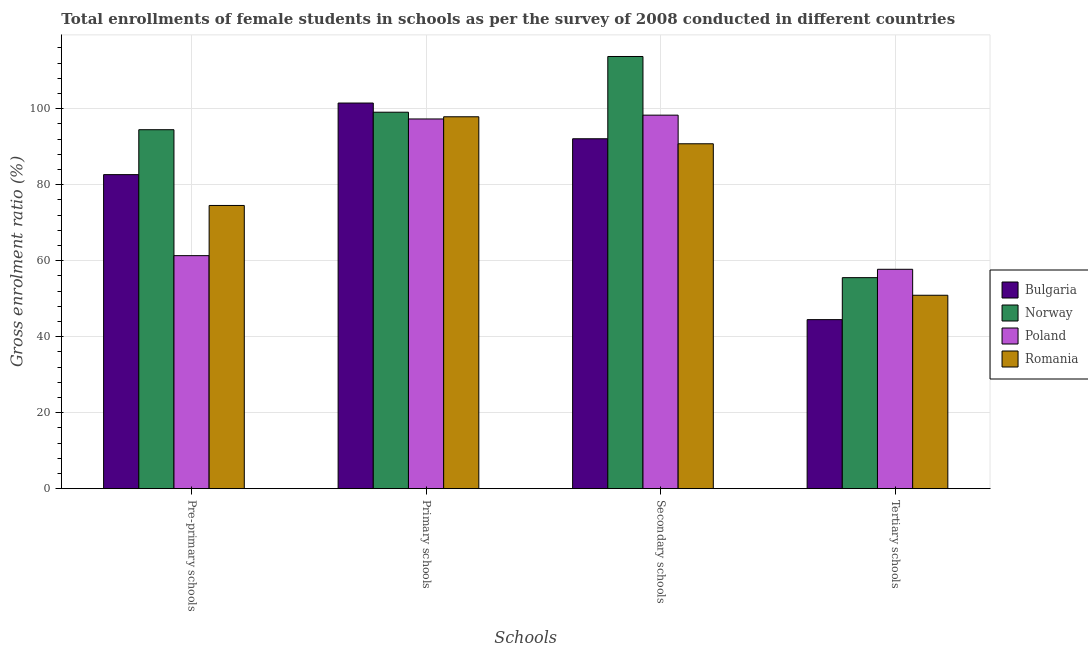Are the number of bars per tick equal to the number of legend labels?
Keep it short and to the point. Yes. Are the number of bars on each tick of the X-axis equal?
Provide a short and direct response. Yes. How many bars are there on the 1st tick from the right?
Your answer should be very brief. 4. What is the label of the 2nd group of bars from the left?
Provide a succinct answer. Primary schools. What is the gross enrolment ratio(female) in primary schools in Poland?
Provide a short and direct response. 97.31. Across all countries, what is the maximum gross enrolment ratio(female) in secondary schools?
Provide a succinct answer. 113.75. Across all countries, what is the minimum gross enrolment ratio(female) in secondary schools?
Ensure brevity in your answer.  90.78. In which country was the gross enrolment ratio(female) in primary schools minimum?
Your answer should be very brief. Poland. What is the total gross enrolment ratio(female) in tertiary schools in the graph?
Make the answer very short. 208.68. What is the difference between the gross enrolment ratio(female) in secondary schools in Bulgaria and that in Romania?
Keep it short and to the point. 1.32. What is the difference between the gross enrolment ratio(female) in secondary schools in Norway and the gross enrolment ratio(female) in primary schools in Bulgaria?
Make the answer very short. 12.25. What is the average gross enrolment ratio(female) in pre-primary schools per country?
Keep it short and to the point. 78.25. What is the difference between the gross enrolment ratio(female) in secondary schools and gross enrolment ratio(female) in primary schools in Poland?
Offer a very short reply. 1. In how many countries, is the gross enrolment ratio(female) in secondary schools greater than 48 %?
Your answer should be compact. 4. What is the ratio of the gross enrolment ratio(female) in primary schools in Poland to that in Romania?
Your response must be concise. 0.99. Is the gross enrolment ratio(female) in tertiary schools in Norway less than that in Romania?
Your response must be concise. No. Is the difference between the gross enrolment ratio(female) in tertiary schools in Norway and Bulgaria greater than the difference between the gross enrolment ratio(female) in primary schools in Norway and Bulgaria?
Keep it short and to the point. Yes. What is the difference between the highest and the second highest gross enrolment ratio(female) in secondary schools?
Give a very brief answer. 15.44. What is the difference between the highest and the lowest gross enrolment ratio(female) in pre-primary schools?
Provide a short and direct response. 33.15. In how many countries, is the gross enrolment ratio(female) in pre-primary schools greater than the average gross enrolment ratio(female) in pre-primary schools taken over all countries?
Provide a short and direct response. 2. Is the sum of the gross enrolment ratio(female) in secondary schools in Norway and Romania greater than the maximum gross enrolment ratio(female) in pre-primary schools across all countries?
Provide a succinct answer. Yes. Is it the case that in every country, the sum of the gross enrolment ratio(female) in secondary schools and gross enrolment ratio(female) in pre-primary schools is greater than the sum of gross enrolment ratio(female) in primary schools and gross enrolment ratio(female) in tertiary schools?
Your response must be concise. No. What does the 2nd bar from the left in Primary schools represents?
Ensure brevity in your answer.  Norway. What is the difference between two consecutive major ticks on the Y-axis?
Offer a very short reply. 20. Are the values on the major ticks of Y-axis written in scientific E-notation?
Give a very brief answer. No. Does the graph contain any zero values?
Provide a short and direct response. No. Does the graph contain grids?
Ensure brevity in your answer.  Yes. Where does the legend appear in the graph?
Your answer should be compact. Center right. How many legend labels are there?
Your answer should be compact. 4. What is the title of the graph?
Your response must be concise. Total enrollments of female students in schools as per the survey of 2008 conducted in different countries. Does "Azerbaijan" appear as one of the legend labels in the graph?
Ensure brevity in your answer.  No. What is the label or title of the X-axis?
Your answer should be compact. Schools. What is the label or title of the Y-axis?
Offer a very short reply. Gross enrolment ratio (%). What is the Gross enrolment ratio (%) of Bulgaria in Pre-primary schools?
Ensure brevity in your answer.  82.66. What is the Gross enrolment ratio (%) of Norway in Pre-primary schools?
Your answer should be very brief. 94.48. What is the Gross enrolment ratio (%) of Poland in Pre-primary schools?
Your response must be concise. 61.33. What is the Gross enrolment ratio (%) in Romania in Pre-primary schools?
Give a very brief answer. 74.54. What is the Gross enrolment ratio (%) in Bulgaria in Primary schools?
Your response must be concise. 101.5. What is the Gross enrolment ratio (%) in Norway in Primary schools?
Keep it short and to the point. 99.09. What is the Gross enrolment ratio (%) of Poland in Primary schools?
Ensure brevity in your answer.  97.31. What is the Gross enrolment ratio (%) of Romania in Primary schools?
Your response must be concise. 97.89. What is the Gross enrolment ratio (%) of Bulgaria in Secondary schools?
Keep it short and to the point. 92.1. What is the Gross enrolment ratio (%) in Norway in Secondary schools?
Ensure brevity in your answer.  113.75. What is the Gross enrolment ratio (%) in Poland in Secondary schools?
Provide a short and direct response. 98.31. What is the Gross enrolment ratio (%) in Romania in Secondary schools?
Keep it short and to the point. 90.78. What is the Gross enrolment ratio (%) of Bulgaria in Tertiary schools?
Ensure brevity in your answer.  44.49. What is the Gross enrolment ratio (%) in Norway in Tertiary schools?
Provide a short and direct response. 55.54. What is the Gross enrolment ratio (%) in Poland in Tertiary schools?
Offer a terse response. 57.74. What is the Gross enrolment ratio (%) of Romania in Tertiary schools?
Offer a terse response. 50.91. Across all Schools, what is the maximum Gross enrolment ratio (%) of Bulgaria?
Provide a short and direct response. 101.5. Across all Schools, what is the maximum Gross enrolment ratio (%) of Norway?
Ensure brevity in your answer.  113.75. Across all Schools, what is the maximum Gross enrolment ratio (%) of Poland?
Your response must be concise. 98.31. Across all Schools, what is the maximum Gross enrolment ratio (%) of Romania?
Provide a short and direct response. 97.89. Across all Schools, what is the minimum Gross enrolment ratio (%) of Bulgaria?
Make the answer very short. 44.49. Across all Schools, what is the minimum Gross enrolment ratio (%) of Norway?
Provide a short and direct response. 55.54. Across all Schools, what is the minimum Gross enrolment ratio (%) of Poland?
Make the answer very short. 57.74. Across all Schools, what is the minimum Gross enrolment ratio (%) in Romania?
Offer a terse response. 50.91. What is the total Gross enrolment ratio (%) in Bulgaria in the graph?
Provide a succinct answer. 320.75. What is the total Gross enrolment ratio (%) of Norway in the graph?
Your answer should be very brief. 362.86. What is the total Gross enrolment ratio (%) in Poland in the graph?
Your answer should be very brief. 314.7. What is the total Gross enrolment ratio (%) of Romania in the graph?
Offer a terse response. 314.12. What is the difference between the Gross enrolment ratio (%) of Bulgaria in Pre-primary schools and that in Primary schools?
Offer a terse response. -18.84. What is the difference between the Gross enrolment ratio (%) of Norway in Pre-primary schools and that in Primary schools?
Your answer should be very brief. -4.6. What is the difference between the Gross enrolment ratio (%) of Poland in Pre-primary schools and that in Primary schools?
Provide a short and direct response. -35.98. What is the difference between the Gross enrolment ratio (%) of Romania in Pre-primary schools and that in Primary schools?
Your response must be concise. -23.35. What is the difference between the Gross enrolment ratio (%) in Bulgaria in Pre-primary schools and that in Secondary schools?
Provide a succinct answer. -9.44. What is the difference between the Gross enrolment ratio (%) of Norway in Pre-primary schools and that in Secondary schools?
Your answer should be compact. -19.27. What is the difference between the Gross enrolment ratio (%) in Poland in Pre-primary schools and that in Secondary schools?
Your answer should be very brief. -36.98. What is the difference between the Gross enrolment ratio (%) in Romania in Pre-primary schools and that in Secondary schools?
Your answer should be compact. -16.24. What is the difference between the Gross enrolment ratio (%) of Bulgaria in Pre-primary schools and that in Tertiary schools?
Offer a very short reply. 38.17. What is the difference between the Gross enrolment ratio (%) in Norway in Pre-primary schools and that in Tertiary schools?
Ensure brevity in your answer.  38.94. What is the difference between the Gross enrolment ratio (%) of Poland in Pre-primary schools and that in Tertiary schools?
Your answer should be compact. 3.59. What is the difference between the Gross enrolment ratio (%) of Romania in Pre-primary schools and that in Tertiary schools?
Offer a terse response. 23.63. What is the difference between the Gross enrolment ratio (%) of Bulgaria in Primary schools and that in Secondary schools?
Your response must be concise. 9.4. What is the difference between the Gross enrolment ratio (%) in Norway in Primary schools and that in Secondary schools?
Your answer should be compact. -14.67. What is the difference between the Gross enrolment ratio (%) of Poland in Primary schools and that in Secondary schools?
Your answer should be compact. -1. What is the difference between the Gross enrolment ratio (%) of Romania in Primary schools and that in Secondary schools?
Your answer should be compact. 7.11. What is the difference between the Gross enrolment ratio (%) of Bulgaria in Primary schools and that in Tertiary schools?
Make the answer very short. 57.01. What is the difference between the Gross enrolment ratio (%) of Norway in Primary schools and that in Tertiary schools?
Give a very brief answer. 43.54. What is the difference between the Gross enrolment ratio (%) of Poland in Primary schools and that in Tertiary schools?
Provide a short and direct response. 39.57. What is the difference between the Gross enrolment ratio (%) in Romania in Primary schools and that in Tertiary schools?
Your answer should be very brief. 46.98. What is the difference between the Gross enrolment ratio (%) in Bulgaria in Secondary schools and that in Tertiary schools?
Make the answer very short. 47.61. What is the difference between the Gross enrolment ratio (%) of Norway in Secondary schools and that in Tertiary schools?
Offer a very short reply. 58.21. What is the difference between the Gross enrolment ratio (%) in Poland in Secondary schools and that in Tertiary schools?
Ensure brevity in your answer.  40.57. What is the difference between the Gross enrolment ratio (%) in Romania in Secondary schools and that in Tertiary schools?
Make the answer very short. 39.87. What is the difference between the Gross enrolment ratio (%) in Bulgaria in Pre-primary schools and the Gross enrolment ratio (%) in Norway in Primary schools?
Ensure brevity in your answer.  -16.43. What is the difference between the Gross enrolment ratio (%) in Bulgaria in Pre-primary schools and the Gross enrolment ratio (%) in Poland in Primary schools?
Your response must be concise. -14.65. What is the difference between the Gross enrolment ratio (%) in Bulgaria in Pre-primary schools and the Gross enrolment ratio (%) in Romania in Primary schools?
Your response must be concise. -15.23. What is the difference between the Gross enrolment ratio (%) in Norway in Pre-primary schools and the Gross enrolment ratio (%) in Poland in Primary schools?
Provide a short and direct response. -2.83. What is the difference between the Gross enrolment ratio (%) of Norway in Pre-primary schools and the Gross enrolment ratio (%) of Romania in Primary schools?
Give a very brief answer. -3.41. What is the difference between the Gross enrolment ratio (%) of Poland in Pre-primary schools and the Gross enrolment ratio (%) of Romania in Primary schools?
Make the answer very short. -36.55. What is the difference between the Gross enrolment ratio (%) of Bulgaria in Pre-primary schools and the Gross enrolment ratio (%) of Norway in Secondary schools?
Give a very brief answer. -31.09. What is the difference between the Gross enrolment ratio (%) of Bulgaria in Pre-primary schools and the Gross enrolment ratio (%) of Poland in Secondary schools?
Your response must be concise. -15.65. What is the difference between the Gross enrolment ratio (%) of Bulgaria in Pre-primary schools and the Gross enrolment ratio (%) of Romania in Secondary schools?
Offer a terse response. -8.12. What is the difference between the Gross enrolment ratio (%) of Norway in Pre-primary schools and the Gross enrolment ratio (%) of Poland in Secondary schools?
Give a very brief answer. -3.83. What is the difference between the Gross enrolment ratio (%) of Norway in Pre-primary schools and the Gross enrolment ratio (%) of Romania in Secondary schools?
Your response must be concise. 3.7. What is the difference between the Gross enrolment ratio (%) of Poland in Pre-primary schools and the Gross enrolment ratio (%) of Romania in Secondary schools?
Your answer should be very brief. -29.44. What is the difference between the Gross enrolment ratio (%) in Bulgaria in Pre-primary schools and the Gross enrolment ratio (%) in Norway in Tertiary schools?
Provide a short and direct response. 27.12. What is the difference between the Gross enrolment ratio (%) in Bulgaria in Pre-primary schools and the Gross enrolment ratio (%) in Poland in Tertiary schools?
Offer a terse response. 24.92. What is the difference between the Gross enrolment ratio (%) of Bulgaria in Pre-primary schools and the Gross enrolment ratio (%) of Romania in Tertiary schools?
Keep it short and to the point. 31.75. What is the difference between the Gross enrolment ratio (%) of Norway in Pre-primary schools and the Gross enrolment ratio (%) of Poland in Tertiary schools?
Your answer should be compact. 36.74. What is the difference between the Gross enrolment ratio (%) in Norway in Pre-primary schools and the Gross enrolment ratio (%) in Romania in Tertiary schools?
Ensure brevity in your answer.  43.57. What is the difference between the Gross enrolment ratio (%) of Poland in Pre-primary schools and the Gross enrolment ratio (%) of Romania in Tertiary schools?
Give a very brief answer. 10.43. What is the difference between the Gross enrolment ratio (%) of Bulgaria in Primary schools and the Gross enrolment ratio (%) of Norway in Secondary schools?
Your answer should be compact. -12.25. What is the difference between the Gross enrolment ratio (%) of Bulgaria in Primary schools and the Gross enrolment ratio (%) of Poland in Secondary schools?
Keep it short and to the point. 3.19. What is the difference between the Gross enrolment ratio (%) of Bulgaria in Primary schools and the Gross enrolment ratio (%) of Romania in Secondary schools?
Offer a very short reply. 10.72. What is the difference between the Gross enrolment ratio (%) of Norway in Primary schools and the Gross enrolment ratio (%) of Poland in Secondary schools?
Make the answer very short. 0.77. What is the difference between the Gross enrolment ratio (%) in Norway in Primary schools and the Gross enrolment ratio (%) in Romania in Secondary schools?
Give a very brief answer. 8.31. What is the difference between the Gross enrolment ratio (%) in Poland in Primary schools and the Gross enrolment ratio (%) in Romania in Secondary schools?
Offer a very short reply. 6.53. What is the difference between the Gross enrolment ratio (%) of Bulgaria in Primary schools and the Gross enrolment ratio (%) of Norway in Tertiary schools?
Your answer should be very brief. 45.96. What is the difference between the Gross enrolment ratio (%) in Bulgaria in Primary schools and the Gross enrolment ratio (%) in Poland in Tertiary schools?
Your response must be concise. 43.76. What is the difference between the Gross enrolment ratio (%) of Bulgaria in Primary schools and the Gross enrolment ratio (%) of Romania in Tertiary schools?
Provide a short and direct response. 50.59. What is the difference between the Gross enrolment ratio (%) of Norway in Primary schools and the Gross enrolment ratio (%) of Poland in Tertiary schools?
Make the answer very short. 41.34. What is the difference between the Gross enrolment ratio (%) of Norway in Primary schools and the Gross enrolment ratio (%) of Romania in Tertiary schools?
Offer a very short reply. 48.18. What is the difference between the Gross enrolment ratio (%) of Poland in Primary schools and the Gross enrolment ratio (%) of Romania in Tertiary schools?
Keep it short and to the point. 46.4. What is the difference between the Gross enrolment ratio (%) in Bulgaria in Secondary schools and the Gross enrolment ratio (%) in Norway in Tertiary schools?
Give a very brief answer. 36.56. What is the difference between the Gross enrolment ratio (%) of Bulgaria in Secondary schools and the Gross enrolment ratio (%) of Poland in Tertiary schools?
Make the answer very short. 34.36. What is the difference between the Gross enrolment ratio (%) in Bulgaria in Secondary schools and the Gross enrolment ratio (%) in Romania in Tertiary schools?
Your answer should be compact. 41.19. What is the difference between the Gross enrolment ratio (%) in Norway in Secondary schools and the Gross enrolment ratio (%) in Poland in Tertiary schools?
Provide a short and direct response. 56.01. What is the difference between the Gross enrolment ratio (%) of Norway in Secondary schools and the Gross enrolment ratio (%) of Romania in Tertiary schools?
Offer a terse response. 62.85. What is the difference between the Gross enrolment ratio (%) of Poland in Secondary schools and the Gross enrolment ratio (%) of Romania in Tertiary schools?
Your answer should be very brief. 47.41. What is the average Gross enrolment ratio (%) of Bulgaria per Schools?
Offer a terse response. 80.19. What is the average Gross enrolment ratio (%) of Norway per Schools?
Your response must be concise. 90.72. What is the average Gross enrolment ratio (%) of Poland per Schools?
Offer a terse response. 78.67. What is the average Gross enrolment ratio (%) of Romania per Schools?
Make the answer very short. 78.53. What is the difference between the Gross enrolment ratio (%) of Bulgaria and Gross enrolment ratio (%) of Norway in Pre-primary schools?
Make the answer very short. -11.82. What is the difference between the Gross enrolment ratio (%) in Bulgaria and Gross enrolment ratio (%) in Poland in Pre-primary schools?
Give a very brief answer. 21.33. What is the difference between the Gross enrolment ratio (%) in Bulgaria and Gross enrolment ratio (%) in Romania in Pre-primary schools?
Offer a terse response. 8.12. What is the difference between the Gross enrolment ratio (%) in Norway and Gross enrolment ratio (%) in Poland in Pre-primary schools?
Offer a terse response. 33.15. What is the difference between the Gross enrolment ratio (%) of Norway and Gross enrolment ratio (%) of Romania in Pre-primary schools?
Offer a terse response. 19.94. What is the difference between the Gross enrolment ratio (%) of Poland and Gross enrolment ratio (%) of Romania in Pre-primary schools?
Ensure brevity in your answer.  -13.21. What is the difference between the Gross enrolment ratio (%) of Bulgaria and Gross enrolment ratio (%) of Norway in Primary schools?
Ensure brevity in your answer.  2.42. What is the difference between the Gross enrolment ratio (%) in Bulgaria and Gross enrolment ratio (%) in Poland in Primary schools?
Ensure brevity in your answer.  4.19. What is the difference between the Gross enrolment ratio (%) in Bulgaria and Gross enrolment ratio (%) in Romania in Primary schools?
Ensure brevity in your answer.  3.61. What is the difference between the Gross enrolment ratio (%) in Norway and Gross enrolment ratio (%) in Poland in Primary schools?
Provide a succinct answer. 1.78. What is the difference between the Gross enrolment ratio (%) in Norway and Gross enrolment ratio (%) in Romania in Primary schools?
Your answer should be compact. 1.2. What is the difference between the Gross enrolment ratio (%) in Poland and Gross enrolment ratio (%) in Romania in Primary schools?
Ensure brevity in your answer.  -0.58. What is the difference between the Gross enrolment ratio (%) of Bulgaria and Gross enrolment ratio (%) of Norway in Secondary schools?
Your answer should be very brief. -21.66. What is the difference between the Gross enrolment ratio (%) in Bulgaria and Gross enrolment ratio (%) in Poland in Secondary schools?
Your response must be concise. -6.22. What is the difference between the Gross enrolment ratio (%) of Bulgaria and Gross enrolment ratio (%) of Romania in Secondary schools?
Your answer should be very brief. 1.32. What is the difference between the Gross enrolment ratio (%) in Norway and Gross enrolment ratio (%) in Poland in Secondary schools?
Make the answer very short. 15.44. What is the difference between the Gross enrolment ratio (%) in Norway and Gross enrolment ratio (%) in Romania in Secondary schools?
Keep it short and to the point. 22.98. What is the difference between the Gross enrolment ratio (%) of Poland and Gross enrolment ratio (%) of Romania in Secondary schools?
Offer a very short reply. 7.54. What is the difference between the Gross enrolment ratio (%) of Bulgaria and Gross enrolment ratio (%) of Norway in Tertiary schools?
Provide a short and direct response. -11.05. What is the difference between the Gross enrolment ratio (%) of Bulgaria and Gross enrolment ratio (%) of Poland in Tertiary schools?
Ensure brevity in your answer.  -13.25. What is the difference between the Gross enrolment ratio (%) of Bulgaria and Gross enrolment ratio (%) of Romania in Tertiary schools?
Your answer should be very brief. -6.42. What is the difference between the Gross enrolment ratio (%) of Norway and Gross enrolment ratio (%) of Poland in Tertiary schools?
Keep it short and to the point. -2.2. What is the difference between the Gross enrolment ratio (%) in Norway and Gross enrolment ratio (%) in Romania in Tertiary schools?
Your answer should be very brief. 4.63. What is the difference between the Gross enrolment ratio (%) of Poland and Gross enrolment ratio (%) of Romania in Tertiary schools?
Your response must be concise. 6.83. What is the ratio of the Gross enrolment ratio (%) of Bulgaria in Pre-primary schools to that in Primary schools?
Your answer should be very brief. 0.81. What is the ratio of the Gross enrolment ratio (%) of Norway in Pre-primary schools to that in Primary schools?
Your response must be concise. 0.95. What is the ratio of the Gross enrolment ratio (%) of Poland in Pre-primary schools to that in Primary schools?
Offer a very short reply. 0.63. What is the ratio of the Gross enrolment ratio (%) in Romania in Pre-primary schools to that in Primary schools?
Keep it short and to the point. 0.76. What is the ratio of the Gross enrolment ratio (%) in Bulgaria in Pre-primary schools to that in Secondary schools?
Provide a short and direct response. 0.9. What is the ratio of the Gross enrolment ratio (%) of Norway in Pre-primary schools to that in Secondary schools?
Your answer should be very brief. 0.83. What is the ratio of the Gross enrolment ratio (%) of Poland in Pre-primary schools to that in Secondary schools?
Your response must be concise. 0.62. What is the ratio of the Gross enrolment ratio (%) in Romania in Pre-primary schools to that in Secondary schools?
Provide a short and direct response. 0.82. What is the ratio of the Gross enrolment ratio (%) of Bulgaria in Pre-primary schools to that in Tertiary schools?
Keep it short and to the point. 1.86. What is the ratio of the Gross enrolment ratio (%) in Norway in Pre-primary schools to that in Tertiary schools?
Make the answer very short. 1.7. What is the ratio of the Gross enrolment ratio (%) in Poland in Pre-primary schools to that in Tertiary schools?
Offer a very short reply. 1.06. What is the ratio of the Gross enrolment ratio (%) in Romania in Pre-primary schools to that in Tertiary schools?
Provide a short and direct response. 1.46. What is the ratio of the Gross enrolment ratio (%) in Bulgaria in Primary schools to that in Secondary schools?
Your answer should be compact. 1.1. What is the ratio of the Gross enrolment ratio (%) of Norway in Primary schools to that in Secondary schools?
Your response must be concise. 0.87. What is the ratio of the Gross enrolment ratio (%) of Romania in Primary schools to that in Secondary schools?
Make the answer very short. 1.08. What is the ratio of the Gross enrolment ratio (%) in Bulgaria in Primary schools to that in Tertiary schools?
Keep it short and to the point. 2.28. What is the ratio of the Gross enrolment ratio (%) in Norway in Primary schools to that in Tertiary schools?
Make the answer very short. 1.78. What is the ratio of the Gross enrolment ratio (%) of Poland in Primary schools to that in Tertiary schools?
Keep it short and to the point. 1.69. What is the ratio of the Gross enrolment ratio (%) of Romania in Primary schools to that in Tertiary schools?
Your answer should be compact. 1.92. What is the ratio of the Gross enrolment ratio (%) in Bulgaria in Secondary schools to that in Tertiary schools?
Your answer should be compact. 2.07. What is the ratio of the Gross enrolment ratio (%) of Norway in Secondary schools to that in Tertiary schools?
Your answer should be compact. 2.05. What is the ratio of the Gross enrolment ratio (%) in Poland in Secondary schools to that in Tertiary schools?
Ensure brevity in your answer.  1.7. What is the ratio of the Gross enrolment ratio (%) in Romania in Secondary schools to that in Tertiary schools?
Ensure brevity in your answer.  1.78. What is the difference between the highest and the second highest Gross enrolment ratio (%) of Bulgaria?
Give a very brief answer. 9.4. What is the difference between the highest and the second highest Gross enrolment ratio (%) in Norway?
Offer a very short reply. 14.67. What is the difference between the highest and the second highest Gross enrolment ratio (%) in Poland?
Offer a terse response. 1. What is the difference between the highest and the second highest Gross enrolment ratio (%) in Romania?
Your answer should be compact. 7.11. What is the difference between the highest and the lowest Gross enrolment ratio (%) in Bulgaria?
Your response must be concise. 57.01. What is the difference between the highest and the lowest Gross enrolment ratio (%) in Norway?
Offer a very short reply. 58.21. What is the difference between the highest and the lowest Gross enrolment ratio (%) in Poland?
Your answer should be compact. 40.57. What is the difference between the highest and the lowest Gross enrolment ratio (%) in Romania?
Keep it short and to the point. 46.98. 